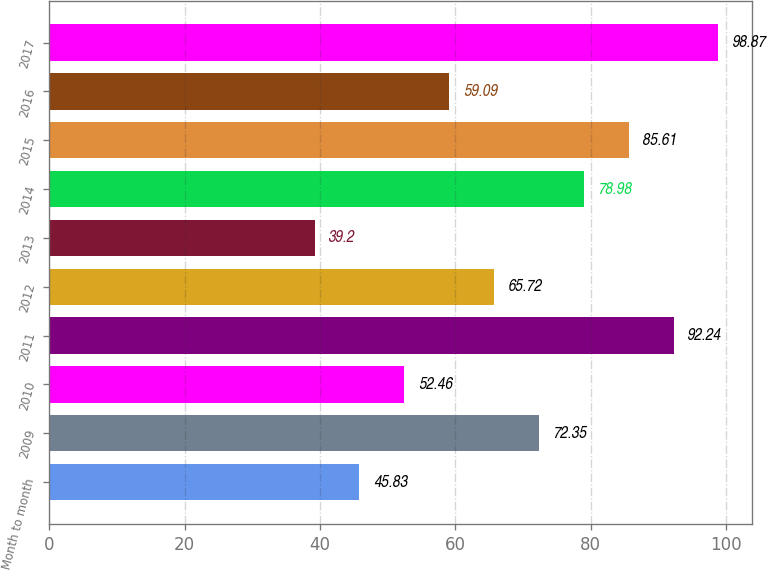Convert chart. <chart><loc_0><loc_0><loc_500><loc_500><bar_chart><fcel>Month to month<fcel>2009<fcel>2010<fcel>2011<fcel>2012<fcel>2013<fcel>2014<fcel>2015<fcel>2016<fcel>2017<nl><fcel>45.83<fcel>72.35<fcel>52.46<fcel>92.24<fcel>65.72<fcel>39.2<fcel>78.98<fcel>85.61<fcel>59.09<fcel>98.87<nl></chart> 